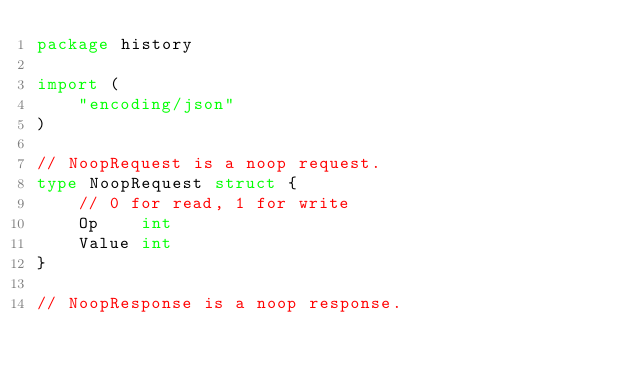Convert code to text. <code><loc_0><loc_0><loc_500><loc_500><_Go_>package history

import (
	"encoding/json"
)

// NoopRequest is a noop request.
type NoopRequest struct {
	// 0 for read, 1 for write
	Op    int
	Value int
}

// NoopResponse is a noop response.</code> 